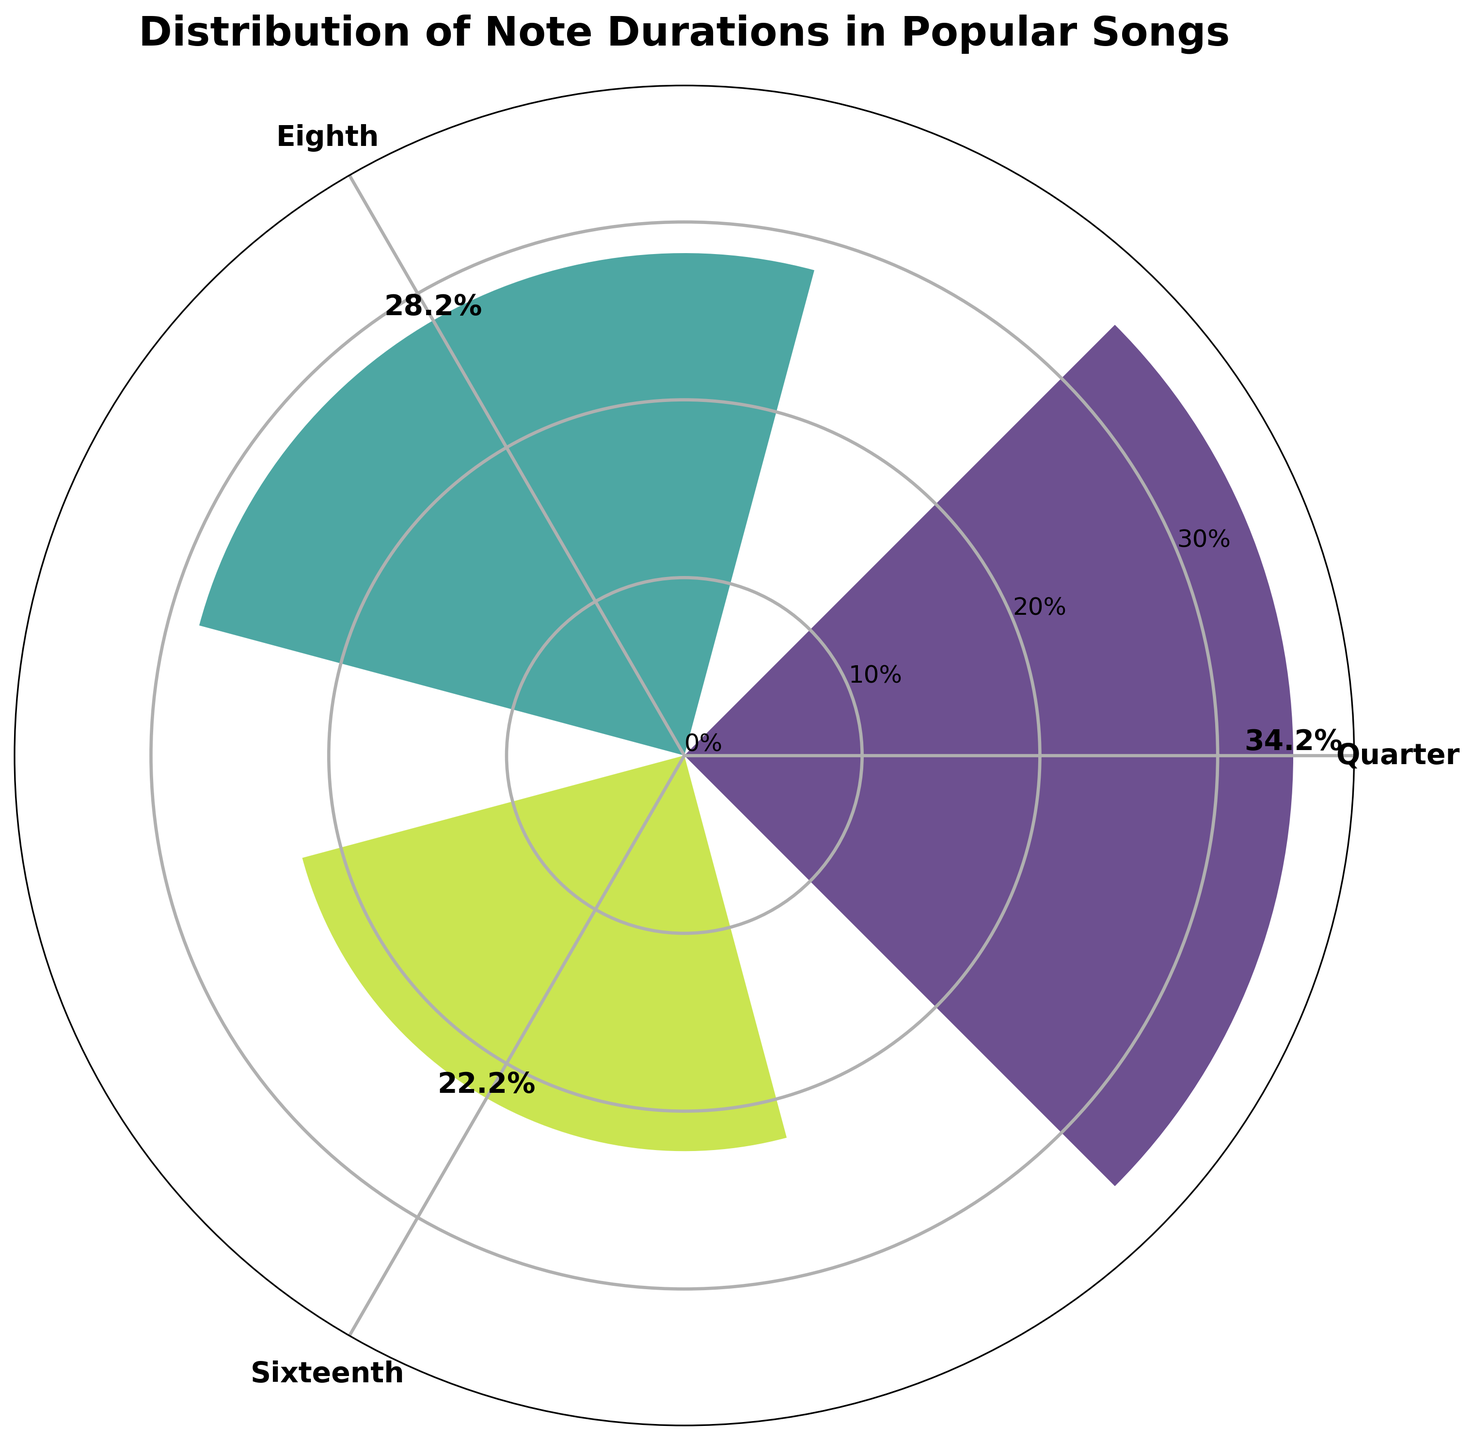What's the title of the chart? The title of the chart is usually located at the top of the figure. This chart's title is "Distribution of Note Durations in Popular Songs," as specified in the code provided.
Answer: Distribution of Note Durations in Popular Songs Which note duration has the highest average percentage in the figure? The highest average percentage is represented by the longest bar. The tallest bar matches the "Quarter" note duration indicating it's the highest.
Answer: Quarter What is the second most common note duration in popular songs according to the chart? The second highest bar indicates the second most common note duration. The bar labeled "Eighth" is the second tallest.
Answer: Eighth How many note durations are displayed in the chart? The chart plots note durations around the polar axis, each labeled and colored. Based on the groupings in the code and data, three are displayed.
Answer: Three What is the average percentage of the "Sixteenth" note duration in the chart? The bar for the "Sixteenth" note duration represents its average percentage value. The corresponding bar's height shows 22.25%.
Answer: 22.25% What are the percentages of the top 3 note durations depicted? The percentages are represented by the heights of the bars. They are labeled directly on the plot. The "Quarter" is 34.25%, the "Eighth" is 28.25%, and "Sixteenth" is 22.25%.
Answer: 34.25%, 28.25%, 22.25% Which note duration has the least average percentage in popular songs shown in the plot? The shortest bar represents the lowest average percentage. The "Half" note duration is not among the top 3 groups, so it has the least.
Answer: Half Compare the average percentages of the "Quarter" and "Eighth" note durations. Which one is greater and by how much? The "Quarter" duration has 34.25% and the "Eighth" has 28.25%. Subtracting these gives 34.25% - 28.25% = 6%.
Answer: Quarter by 6% Does the plot show more than three note durations? The plot selected only the top three note durations based on the average percentages, so it displays only three note durations.
Answer: No 